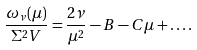<formula> <loc_0><loc_0><loc_500><loc_500>\frac { \omega _ { \nu } ( \mu ) } { \Sigma ^ { 2 } V } = \frac { 2 \nu } { \mu ^ { 2 } } - B - C \mu + \dots .</formula> 